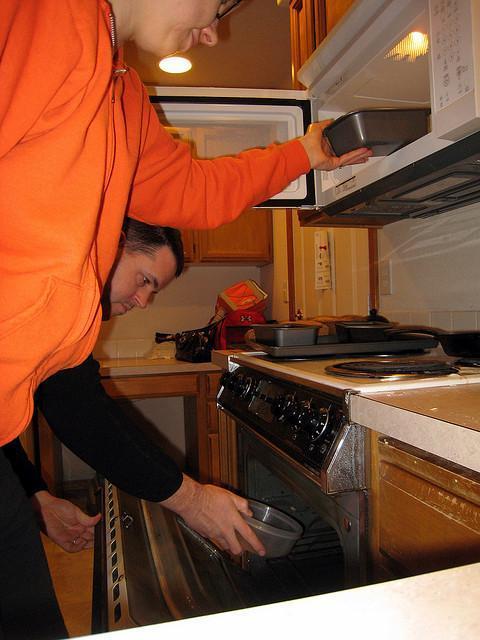How many people are there?
Give a very brief answer. 2. How many ovens are in the picture?
Give a very brief answer. 1. How many elephants can you see?
Give a very brief answer. 0. 